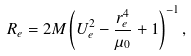<formula> <loc_0><loc_0><loc_500><loc_500>R _ { e } = 2 M \left ( U ^ { 2 } _ { e } - \frac { r ^ { 4 } _ { e } } { \mu _ { 0 } } + 1 \right ) ^ { - 1 } ,</formula> 